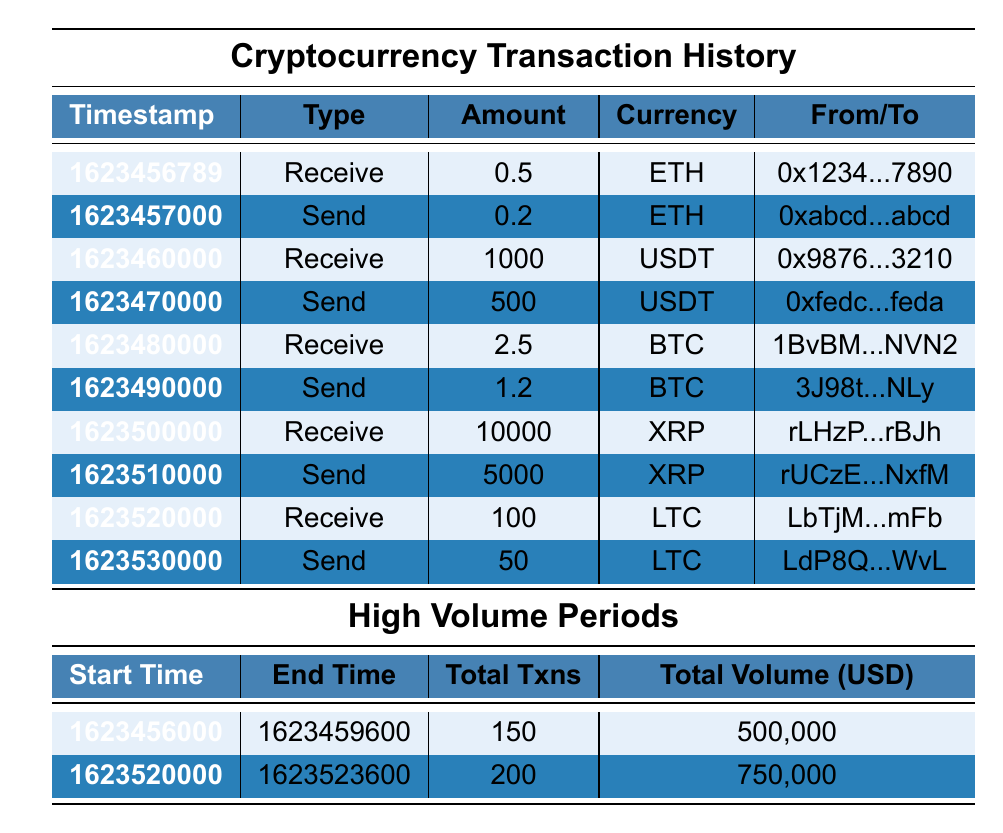What is the total amount received in USDT? There is one transaction for receiving USDT, which is 1000. Thus, the total amount received in USDT is 1000.
Answer: 1000 What is the total number of transactions during the high-volume periods? The table lists two high-volume periods: 150 transactions in the first period and 200 transactions in the second period. Therefore, the total is 150 + 200 = 350.
Answer: 350 Did any transaction involve more than 1000 in cryptocurrency? Yes, there is a transaction that involves receiving 1000 in USDT.
Answer: Yes What was the amount sent in ETH? There is one transaction for sending ETH, which is 0.2. So, the amount sent in ETH is 0.2.
Answer: 0.2 What is the average amount of cryptocurrency received across all transactions? The amounts received are 0.5 (ETH), 1000 (USDT), 2.5 (BTC), 10000 (XRP), and 100 (LTC), totaling 11003.5 from 5 received transactions. Thus, the average is 11003.5 / 5 = 2200.7.
Answer: 2200.7 How many transactions were sent in XRP? Only one transaction for sending XRP is listed, which is for 5000.
Answer: 1 What is the total volume in USD during the high-volume periods? The high-volume periods show a total volume of 500,000 in the first period and 750,000 in the second. Summing these gives 500,000 + 750,000 = 1,250,000.
Answer: 1,250,000 Is there a transaction where Litecoin (LTC) was sent? Yes, there is a transaction where 50 LTC was sent to a specific address.
Answer: Yes What is the difference between the highest and lowest amounts received? The highest received amount is 10000 (XRP) and the lowest is 0.5 (ETH), giving a difference of 10000 - 0.5 = 9999.5.
Answer: 9999.5 How many total transactions are recorded in the table? There are 10 transactions listed in the cryptocurrency transaction history section of the table.
Answer: 10 